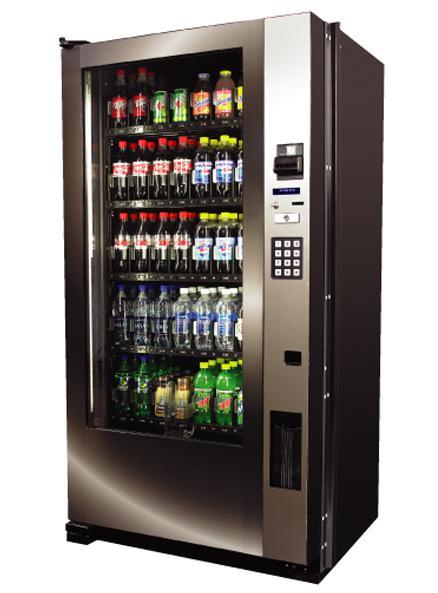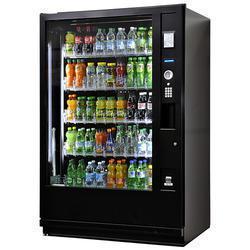The first image is the image on the left, the second image is the image on the right. Examine the images to the left and right. Is the description "At least one vending machine pictured is black with a footed base." accurate? Answer yes or no. No. 